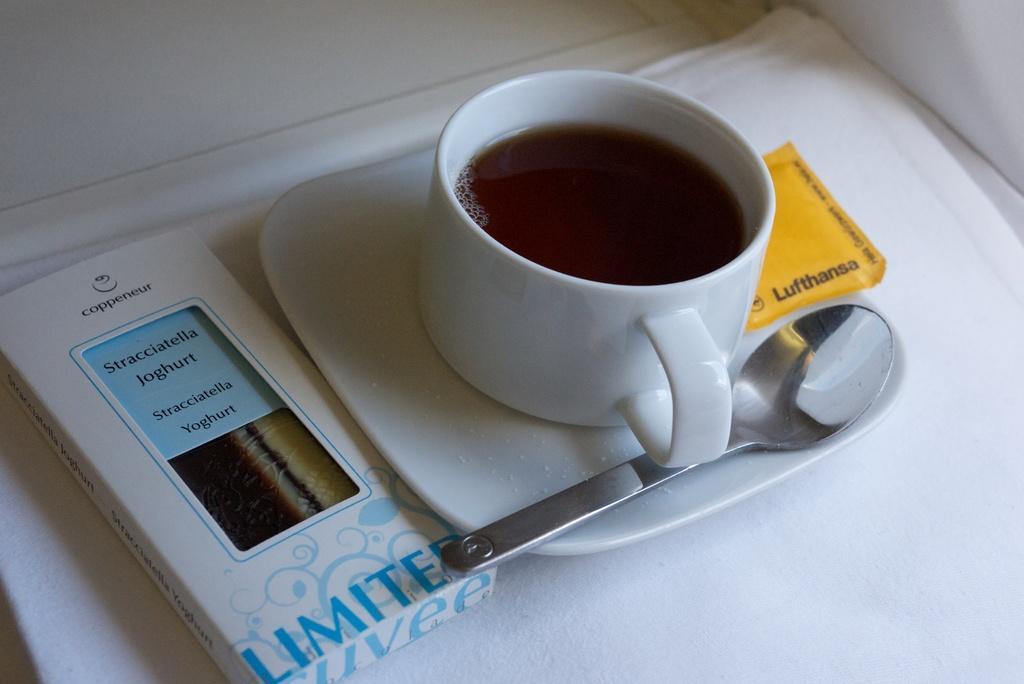In one or two sentences, can you explain what this image depicts? In this picture there is a cup of tea in the center of the image, on a saucer and there is a spoon in the saucer, there is a box on the left side of the image. 